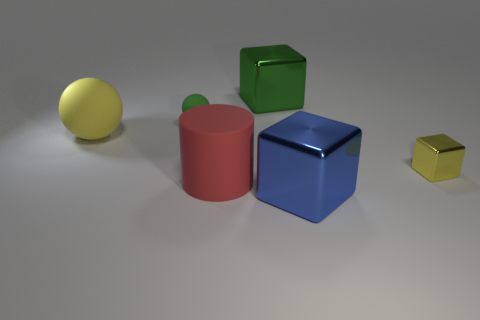Add 1 tiny blue shiny cubes. How many objects exist? 7 Subtract all yellow blocks. How many blocks are left? 2 Add 4 brown cylinders. How many brown cylinders exist? 4 Subtract all yellow spheres. How many spheres are left? 1 Subtract 0 cyan cubes. How many objects are left? 6 Subtract all spheres. How many objects are left? 4 Subtract 1 spheres. How many spheres are left? 1 Subtract all gray blocks. Subtract all blue cylinders. How many blocks are left? 3 Subtract all blue cylinders. How many blue balls are left? 0 Subtract all large gray matte spheres. Subtract all green objects. How many objects are left? 4 